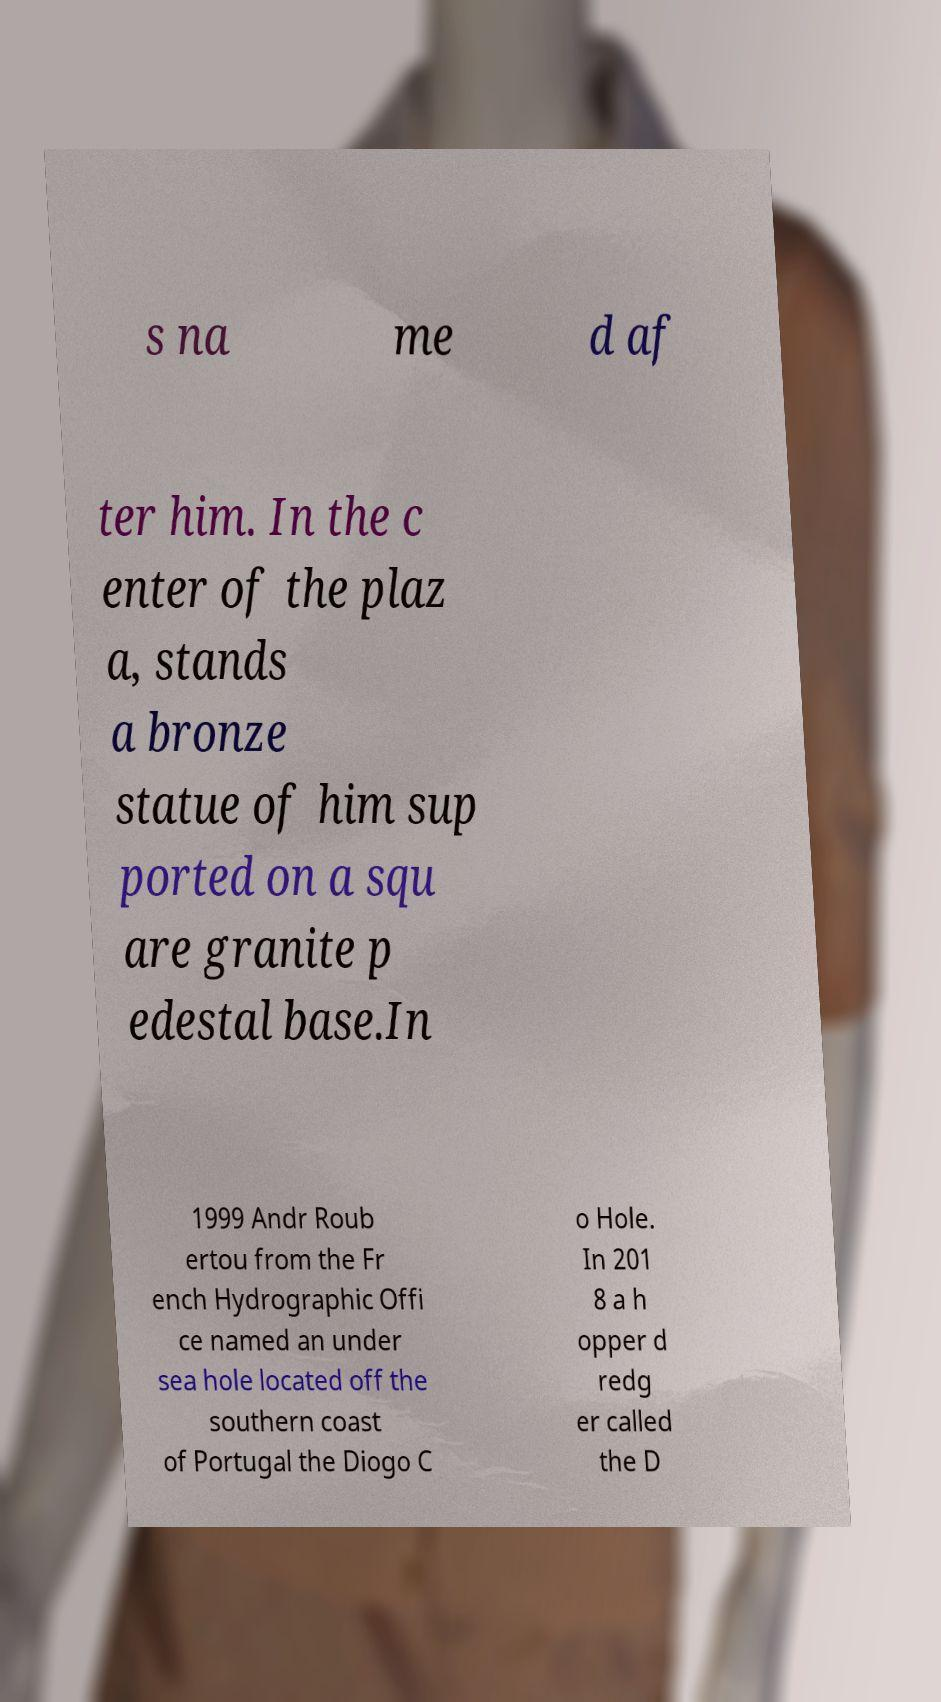I need the written content from this picture converted into text. Can you do that? s na me d af ter him. In the c enter of the plaz a, stands a bronze statue of him sup ported on a squ are granite p edestal base.In 1999 Andr Roub ertou from the Fr ench Hydrographic Offi ce named an under sea hole located off the southern coast of Portugal the Diogo C o Hole. In 201 8 a h opper d redg er called the D 